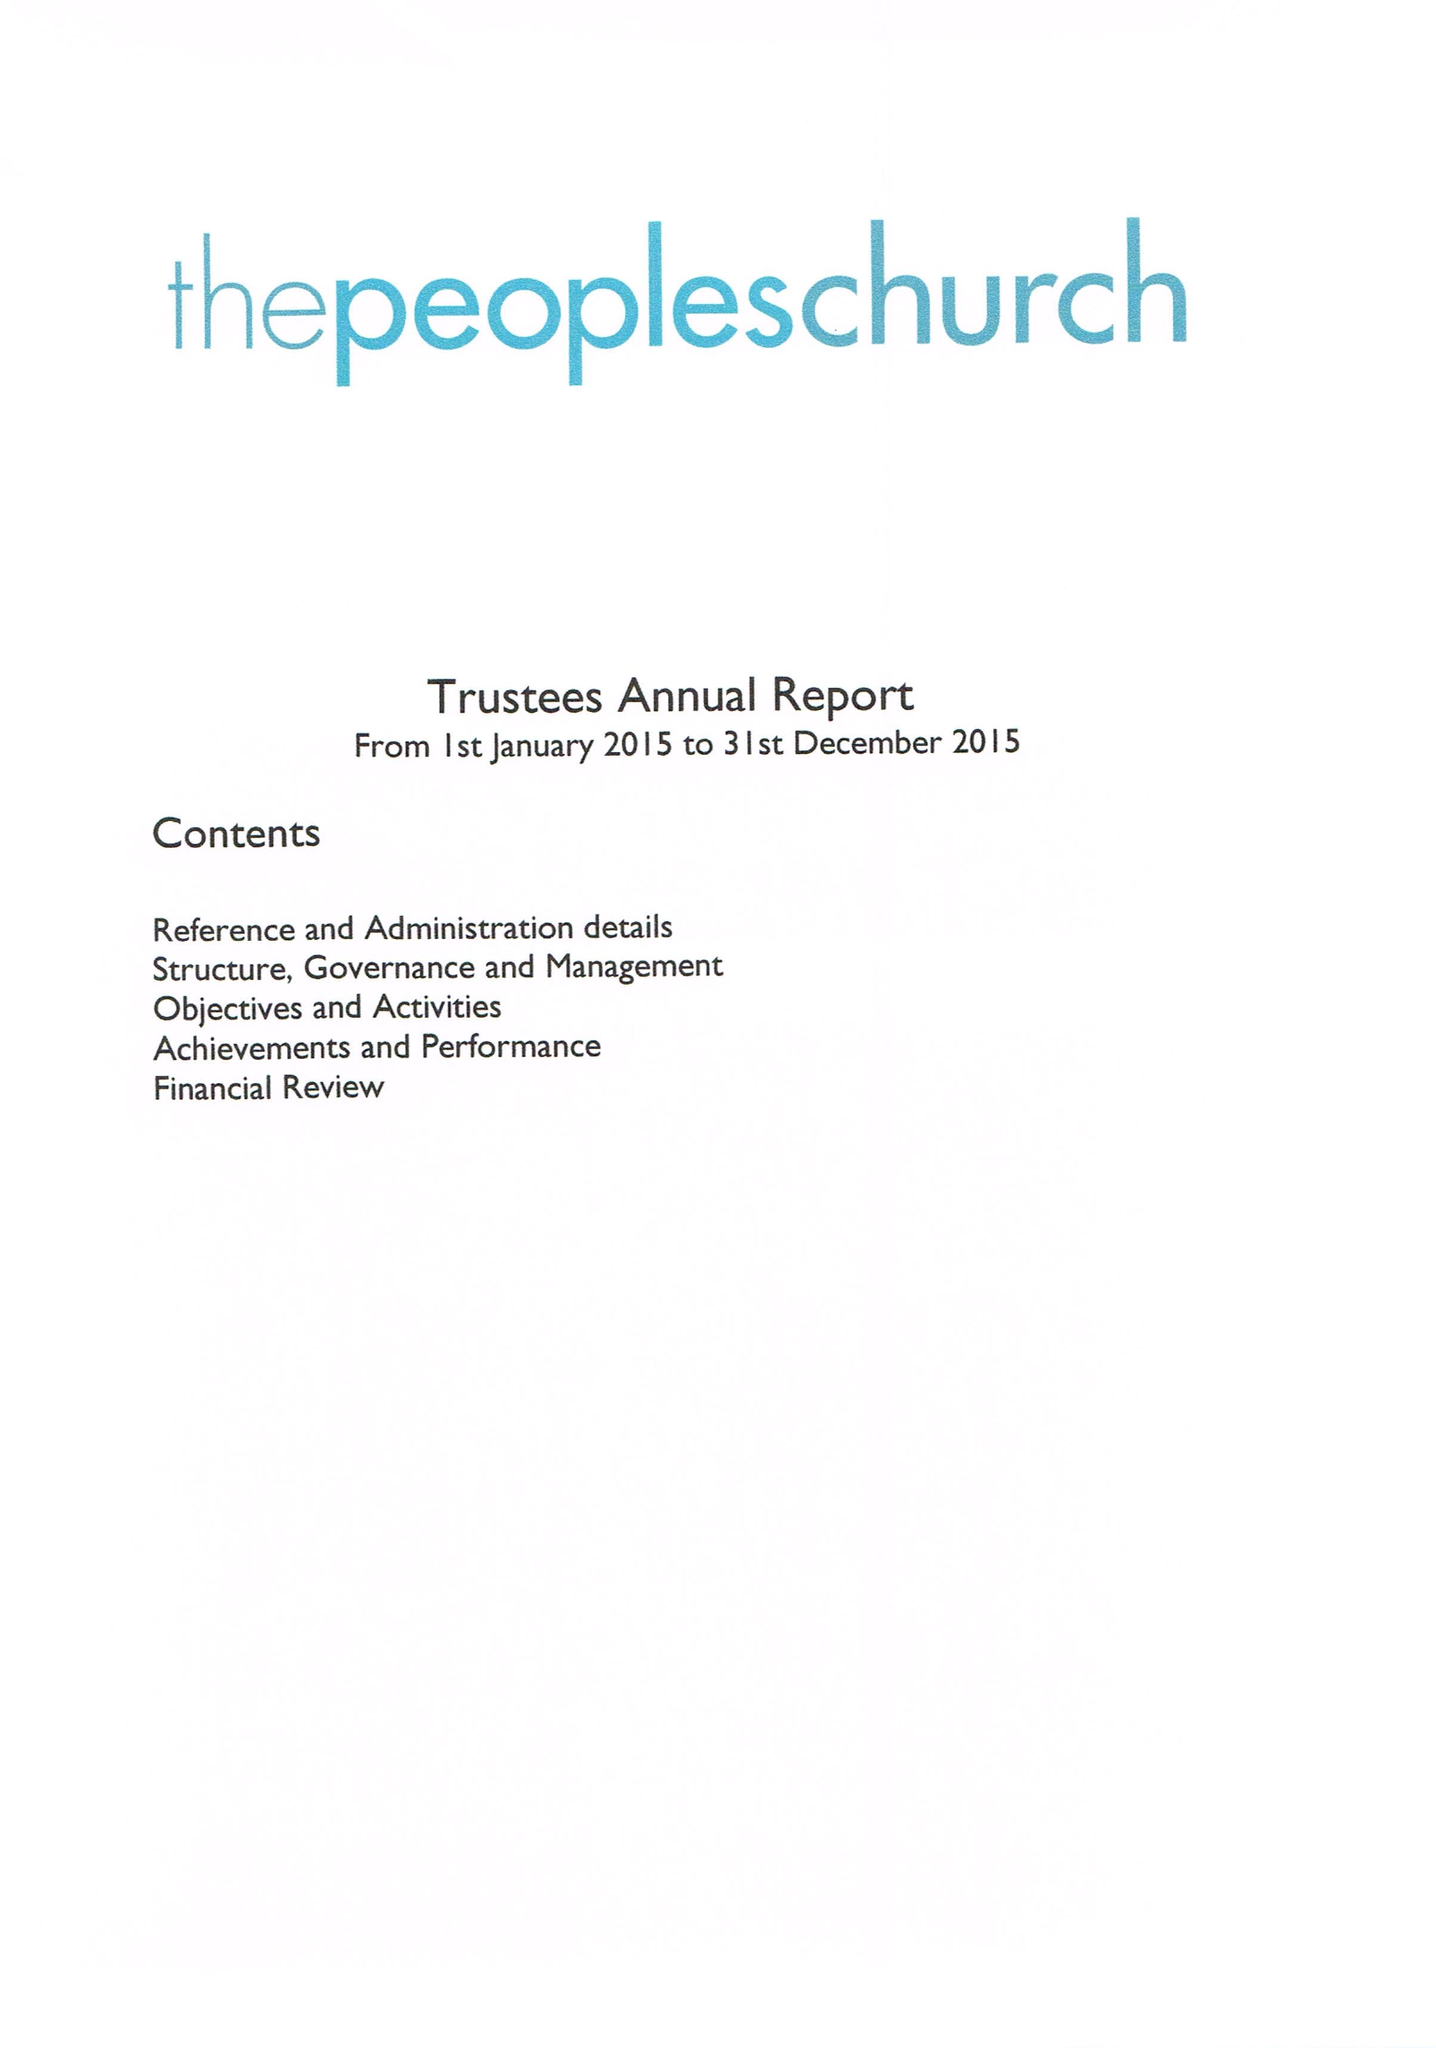What is the value for the address__postcode?
Answer the question using a single word or phrase. OX16 0AH 